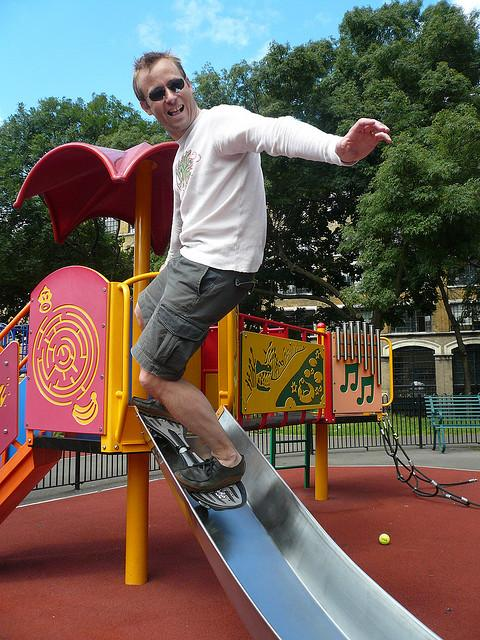The feet of the man are placed on what two wheeled object? skateboard 